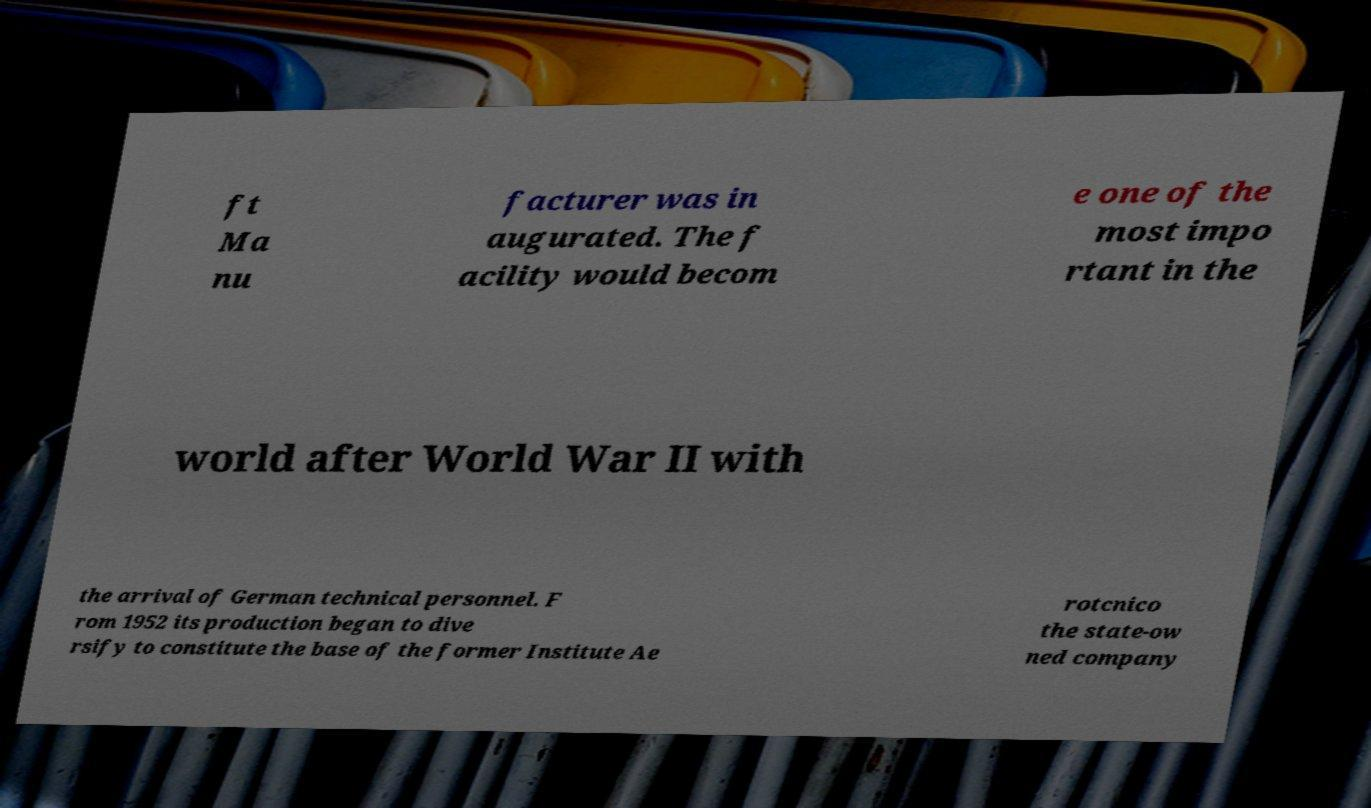Could you extract and type out the text from this image? ft Ma nu facturer was in augurated. The f acility would becom e one of the most impo rtant in the world after World War II with the arrival of German technical personnel. F rom 1952 its production began to dive rsify to constitute the base of the former Institute Ae rotcnico the state-ow ned company 